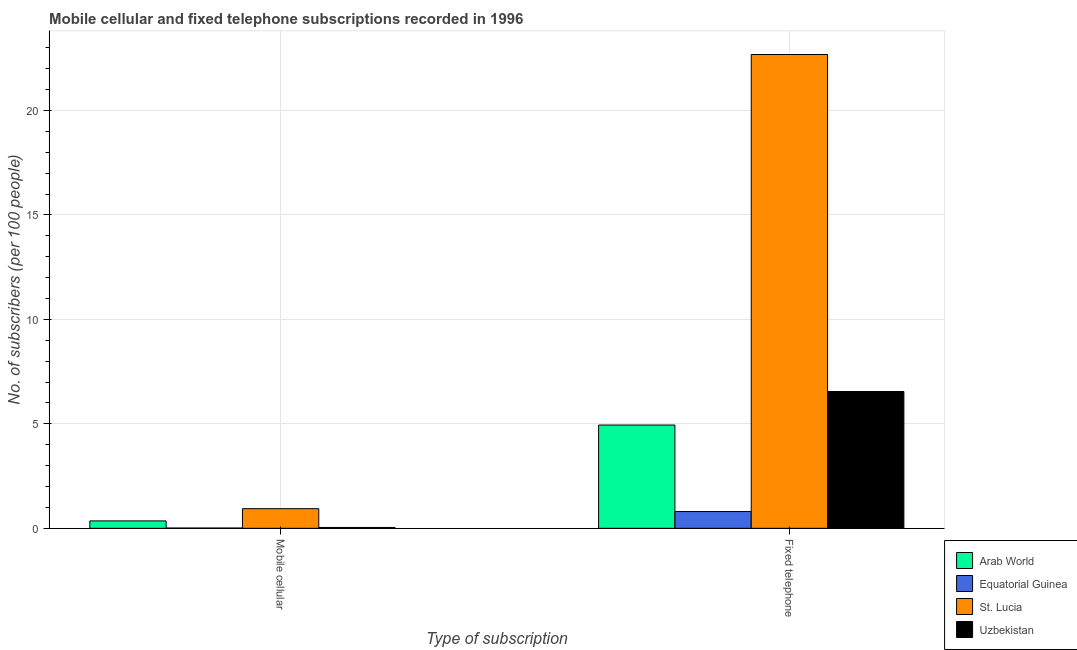How many groups of bars are there?
Provide a succinct answer. 2. Are the number of bars per tick equal to the number of legend labels?
Ensure brevity in your answer.  Yes. How many bars are there on the 1st tick from the left?
Your answer should be compact. 4. What is the label of the 1st group of bars from the left?
Provide a succinct answer. Mobile cellular. What is the number of fixed telephone subscribers in Uzbekistan?
Make the answer very short. 6.55. Across all countries, what is the maximum number of fixed telephone subscribers?
Your answer should be compact. 22.68. Across all countries, what is the minimum number of fixed telephone subscribers?
Give a very brief answer. 0.8. In which country was the number of mobile cellular subscribers maximum?
Your response must be concise. St. Lucia. In which country was the number of fixed telephone subscribers minimum?
Offer a very short reply. Equatorial Guinea. What is the total number of fixed telephone subscribers in the graph?
Offer a very short reply. 34.98. What is the difference between the number of fixed telephone subscribers in Arab World and that in Equatorial Guinea?
Keep it short and to the point. 4.14. What is the difference between the number of fixed telephone subscribers in Equatorial Guinea and the number of mobile cellular subscribers in Arab World?
Provide a succinct answer. 0.45. What is the average number of fixed telephone subscribers per country?
Ensure brevity in your answer.  8.74. What is the difference between the number of mobile cellular subscribers and number of fixed telephone subscribers in Arab World?
Provide a succinct answer. -4.59. What is the ratio of the number of fixed telephone subscribers in Arab World to that in St. Lucia?
Ensure brevity in your answer.  0.22. Is the number of fixed telephone subscribers in St. Lucia less than that in Equatorial Guinea?
Give a very brief answer. No. What does the 4th bar from the left in Fixed telephone represents?
Offer a terse response. Uzbekistan. What does the 2nd bar from the right in Mobile cellular represents?
Make the answer very short. St. Lucia. How many bars are there?
Your answer should be compact. 8. Are all the bars in the graph horizontal?
Provide a short and direct response. No. Does the graph contain grids?
Provide a short and direct response. Yes. Where does the legend appear in the graph?
Offer a terse response. Bottom right. How many legend labels are there?
Provide a short and direct response. 4. How are the legend labels stacked?
Your answer should be compact. Vertical. What is the title of the graph?
Your response must be concise. Mobile cellular and fixed telephone subscriptions recorded in 1996. What is the label or title of the X-axis?
Give a very brief answer. Type of subscription. What is the label or title of the Y-axis?
Give a very brief answer. No. of subscribers (per 100 people). What is the No. of subscribers (per 100 people) in Arab World in Mobile cellular?
Offer a very short reply. 0.36. What is the No. of subscribers (per 100 people) in Equatorial Guinea in Mobile cellular?
Provide a succinct answer. 0.01. What is the No. of subscribers (per 100 people) in St. Lucia in Mobile cellular?
Offer a very short reply. 0.94. What is the No. of subscribers (per 100 people) of Uzbekistan in Mobile cellular?
Provide a short and direct response. 0.04. What is the No. of subscribers (per 100 people) in Arab World in Fixed telephone?
Your answer should be very brief. 4.94. What is the No. of subscribers (per 100 people) of Equatorial Guinea in Fixed telephone?
Your answer should be very brief. 0.8. What is the No. of subscribers (per 100 people) in St. Lucia in Fixed telephone?
Provide a succinct answer. 22.68. What is the No. of subscribers (per 100 people) in Uzbekistan in Fixed telephone?
Ensure brevity in your answer.  6.55. Across all Type of subscription, what is the maximum No. of subscribers (per 100 people) of Arab World?
Give a very brief answer. 4.94. Across all Type of subscription, what is the maximum No. of subscribers (per 100 people) in Equatorial Guinea?
Your response must be concise. 0.8. Across all Type of subscription, what is the maximum No. of subscribers (per 100 people) in St. Lucia?
Keep it short and to the point. 22.68. Across all Type of subscription, what is the maximum No. of subscribers (per 100 people) of Uzbekistan?
Offer a very short reply. 6.55. Across all Type of subscription, what is the minimum No. of subscribers (per 100 people) of Arab World?
Provide a succinct answer. 0.36. Across all Type of subscription, what is the minimum No. of subscribers (per 100 people) in Equatorial Guinea?
Offer a terse response. 0.01. Across all Type of subscription, what is the minimum No. of subscribers (per 100 people) of St. Lucia?
Make the answer very short. 0.94. Across all Type of subscription, what is the minimum No. of subscribers (per 100 people) in Uzbekistan?
Keep it short and to the point. 0.04. What is the total No. of subscribers (per 100 people) in Arab World in the graph?
Give a very brief answer. 5.3. What is the total No. of subscribers (per 100 people) of Equatorial Guinea in the graph?
Offer a terse response. 0.82. What is the total No. of subscribers (per 100 people) of St. Lucia in the graph?
Give a very brief answer. 23.62. What is the total No. of subscribers (per 100 people) in Uzbekistan in the graph?
Provide a succinct answer. 6.59. What is the difference between the No. of subscribers (per 100 people) in Arab World in Mobile cellular and that in Fixed telephone?
Provide a short and direct response. -4.59. What is the difference between the No. of subscribers (per 100 people) in Equatorial Guinea in Mobile cellular and that in Fixed telephone?
Offer a terse response. -0.79. What is the difference between the No. of subscribers (per 100 people) of St. Lucia in Mobile cellular and that in Fixed telephone?
Offer a very short reply. -21.74. What is the difference between the No. of subscribers (per 100 people) of Uzbekistan in Mobile cellular and that in Fixed telephone?
Provide a succinct answer. -6.51. What is the difference between the No. of subscribers (per 100 people) of Arab World in Mobile cellular and the No. of subscribers (per 100 people) of Equatorial Guinea in Fixed telephone?
Ensure brevity in your answer.  -0.45. What is the difference between the No. of subscribers (per 100 people) in Arab World in Mobile cellular and the No. of subscribers (per 100 people) in St. Lucia in Fixed telephone?
Make the answer very short. -22.32. What is the difference between the No. of subscribers (per 100 people) in Arab World in Mobile cellular and the No. of subscribers (per 100 people) in Uzbekistan in Fixed telephone?
Your answer should be very brief. -6.19. What is the difference between the No. of subscribers (per 100 people) of Equatorial Guinea in Mobile cellular and the No. of subscribers (per 100 people) of St. Lucia in Fixed telephone?
Keep it short and to the point. -22.67. What is the difference between the No. of subscribers (per 100 people) in Equatorial Guinea in Mobile cellular and the No. of subscribers (per 100 people) in Uzbekistan in Fixed telephone?
Keep it short and to the point. -6.54. What is the difference between the No. of subscribers (per 100 people) in St. Lucia in Mobile cellular and the No. of subscribers (per 100 people) in Uzbekistan in Fixed telephone?
Ensure brevity in your answer.  -5.61. What is the average No. of subscribers (per 100 people) in Arab World per Type of subscription?
Offer a very short reply. 2.65. What is the average No. of subscribers (per 100 people) of Equatorial Guinea per Type of subscription?
Ensure brevity in your answer.  0.41. What is the average No. of subscribers (per 100 people) in St. Lucia per Type of subscription?
Your answer should be compact. 11.81. What is the average No. of subscribers (per 100 people) of Uzbekistan per Type of subscription?
Offer a very short reply. 3.29. What is the difference between the No. of subscribers (per 100 people) of Arab World and No. of subscribers (per 100 people) of Equatorial Guinea in Mobile cellular?
Your answer should be compact. 0.34. What is the difference between the No. of subscribers (per 100 people) in Arab World and No. of subscribers (per 100 people) in St. Lucia in Mobile cellular?
Make the answer very short. -0.58. What is the difference between the No. of subscribers (per 100 people) in Arab World and No. of subscribers (per 100 people) in Uzbekistan in Mobile cellular?
Your response must be concise. 0.31. What is the difference between the No. of subscribers (per 100 people) of Equatorial Guinea and No. of subscribers (per 100 people) of St. Lucia in Mobile cellular?
Give a very brief answer. -0.93. What is the difference between the No. of subscribers (per 100 people) of Equatorial Guinea and No. of subscribers (per 100 people) of Uzbekistan in Mobile cellular?
Your answer should be compact. -0.03. What is the difference between the No. of subscribers (per 100 people) in St. Lucia and No. of subscribers (per 100 people) in Uzbekistan in Mobile cellular?
Make the answer very short. 0.9. What is the difference between the No. of subscribers (per 100 people) in Arab World and No. of subscribers (per 100 people) in Equatorial Guinea in Fixed telephone?
Provide a short and direct response. 4.14. What is the difference between the No. of subscribers (per 100 people) of Arab World and No. of subscribers (per 100 people) of St. Lucia in Fixed telephone?
Your response must be concise. -17.74. What is the difference between the No. of subscribers (per 100 people) of Arab World and No. of subscribers (per 100 people) of Uzbekistan in Fixed telephone?
Keep it short and to the point. -1.61. What is the difference between the No. of subscribers (per 100 people) of Equatorial Guinea and No. of subscribers (per 100 people) of St. Lucia in Fixed telephone?
Ensure brevity in your answer.  -21.88. What is the difference between the No. of subscribers (per 100 people) in Equatorial Guinea and No. of subscribers (per 100 people) in Uzbekistan in Fixed telephone?
Provide a short and direct response. -5.75. What is the difference between the No. of subscribers (per 100 people) of St. Lucia and No. of subscribers (per 100 people) of Uzbekistan in Fixed telephone?
Your answer should be compact. 16.13. What is the ratio of the No. of subscribers (per 100 people) in Arab World in Mobile cellular to that in Fixed telephone?
Your answer should be compact. 0.07. What is the ratio of the No. of subscribers (per 100 people) of Equatorial Guinea in Mobile cellular to that in Fixed telephone?
Your answer should be compact. 0.02. What is the ratio of the No. of subscribers (per 100 people) in St. Lucia in Mobile cellular to that in Fixed telephone?
Keep it short and to the point. 0.04. What is the ratio of the No. of subscribers (per 100 people) of Uzbekistan in Mobile cellular to that in Fixed telephone?
Your response must be concise. 0.01. What is the difference between the highest and the second highest No. of subscribers (per 100 people) of Arab World?
Your answer should be very brief. 4.59. What is the difference between the highest and the second highest No. of subscribers (per 100 people) in Equatorial Guinea?
Keep it short and to the point. 0.79. What is the difference between the highest and the second highest No. of subscribers (per 100 people) in St. Lucia?
Ensure brevity in your answer.  21.74. What is the difference between the highest and the second highest No. of subscribers (per 100 people) of Uzbekistan?
Offer a very short reply. 6.51. What is the difference between the highest and the lowest No. of subscribers (per 100 people) in Arab World?
Make the answer very short. 4.59. What is the difference between the highest and the lowest No. of subscribers (per 100 people) in Equatorial Guinea?
Offer a terse response. 0.79. What is the difference between the highest and the lowest No. of subscribers (per 100 people) of St. Lucia?
Provide a succinct answer. 21.74. What is the difference between the highest and the lowest No. of subscribers (per 100 people) of Uzbekistan?
Give a very brief answer. 6.51. 